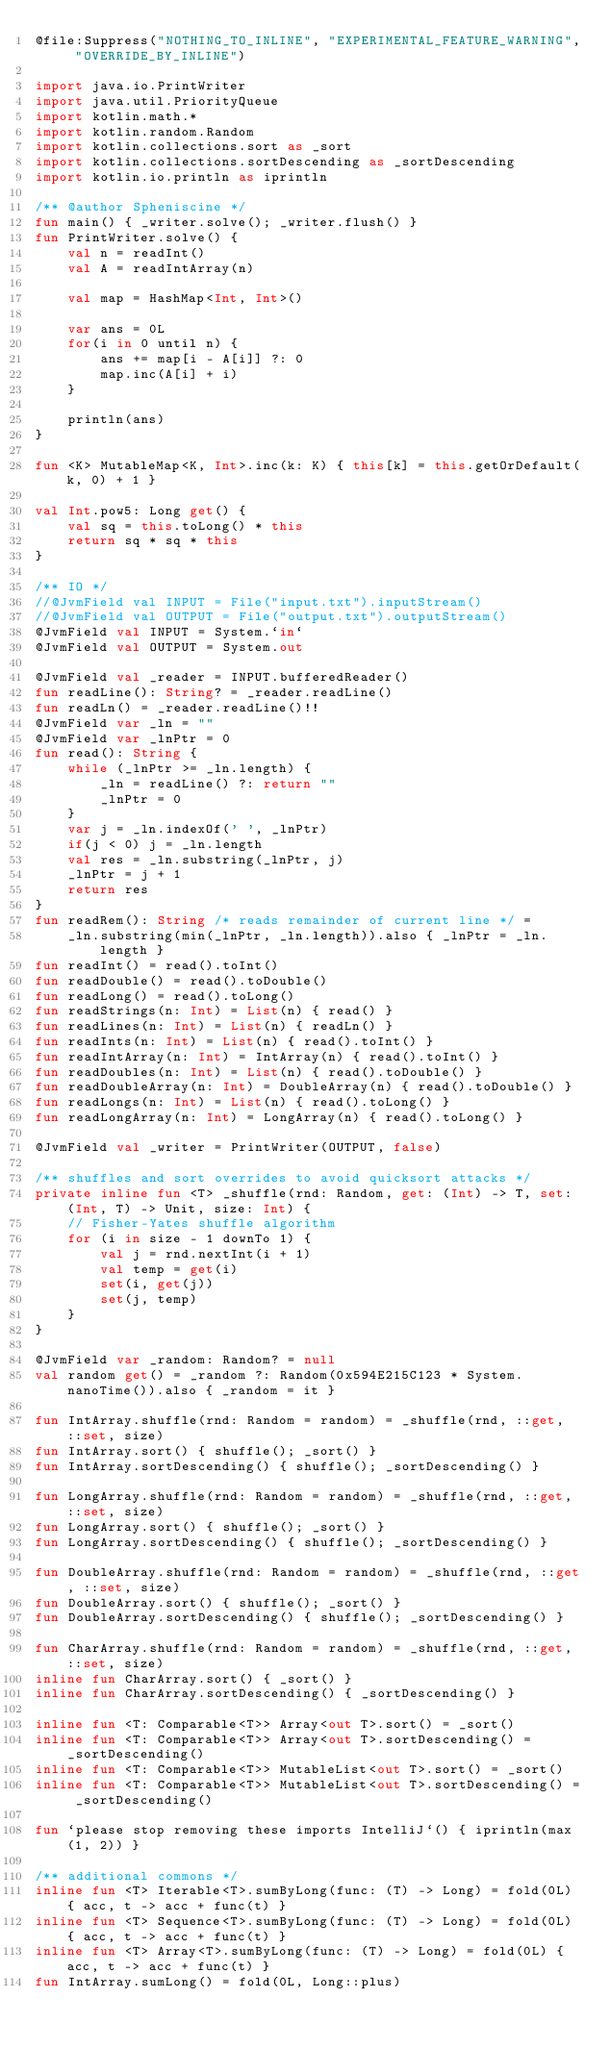Convert code to text. <code><loc_0><loc_0><loc_500><loc_500><_Kotlin_>@file:Suppress("NOTHING_TO_INLINE", "EXPERIMENTAL_FEATURE_WARNING", "OVERRIDE_BY_INLINE")

import java.io.PrintWriter
import java.util.PriorityQueue
import kotlin.math.*
import kotlin.random.Random
import kotlin.collections.sort as _sort
import kotlin.collections.sortDescending as _sortDescending
import kotlin.io.println as iprintln

/** @author Spheniscine */
fun main() { _writer.solve(); _writer.flush() }
fun PrintWriter.solve() {
    val n = readInt()
    val A = readIntArray(n)

    val map = HashMap<Int, Int>()

    var ans = 0L
    for(i in 0 until n) {
        ans += map[i - A[i]] ?: 0
        map.inc(A[i] + i)
    }

    println(ans)
}

fun <K> MutableMap<K, Int>.inc(k: K) { this[k] = this.getOrDefault(k, 0) + 1 }

val Int.pow5: Long get() {
    val sq = this.toLong() * this
    return sq * sq * this
}

/** IO */
//@JvmField val INPUT = File("input.txt").inputStream()
//@JvmField val OUTPUT = File("output.txt").outputStream()
@JvmField val INPUT = System.`in`
@JvmField val OUTPUT = System.out

@JvmField val _reader = INPUT.bufferedReader()
fun readLine(): String? = _reader.readLine()
fun readLn() = _reader.readLine()!!
@JvmField var _ln = ""
@JvmField var _lnPtr = 0
fun read(): String {
    while (_lnPtr >= _ln.length) {
        _ln = readLine() ?: return ""
        _lnPtr = 0
    }
    var j = _ln.indexOf(' ', _lnPtr)
    if(j < 0) j = _ln.length
    val res = _ln.substring(_lnPtr, j)
    _lnPtr = j + 1
    return res
}
fun readRem(): String /* reads remainder of current line */ =
    _ln.substring(min(_lnPtr, _ln.length)).also { _lnPtr = _ln.length }
fun readInt() = read().toInt()
fun readDouble() = read().toDouble()
fun readLong() = read().toLong()
fun readStrings(n: Int) = List(n) { read() }
fun readLines(n: Int) = List(n) { readLn() }
fun readInts(n: Int) = List(n) { read().toInt() }
fun readIntArray(n: Int) = IntArray(n) { read().toInt() }
fun readDoubles(n: Int) = List(n) { read().toDouble() }
fun readDoubleArray(n: Int) = DoubleArray(n) { read().toDouble() }
fun readLongs(n: Int) = List(n) { read().toLong() }
fun readLongArray(n: Int) = LongArray(n) { read().toLong() }

@JvmField val _writer = PrintWriter(OUTPUT, false)

/** shuffles and sort overrides to avoid quicksort attacks */
private inline fun <T> _shuffle(rnd: Random, get: (Int) -> T, set: (Int, T) -> Unit, size: Int) {
    // Fisher-Yates shuffle algorithm
    for (i in size - 1 downTo 1) {
        val j = rnd.nextInt(i + 1)
        val temp = get(i)
        set(i, get(j))
        set(j, temp)
    }
}

@JvmField var _random: Random? = null
val random get() = _random ?: Random(0x594E215C123 * System.nanoTime()).also { _random = it }

fun IntArray.shuffle(rnd: Random = random) = _shuffle(rnd, ::get, ::set, size)
fun IntArray.sort() { shuffle(); _sort() }
fun IntArray.sortDescending() { shuffle(); _sortDescending() }

fun LongArray.shuffle(rnd: Random = random) = _shuffle(rnd, ::get, ::set, size)
fun LongArray.sort() { shuffle(); _sort() }
fun LongArray.sortDescending() { shuffle(); _sortDescending() }

fun DoubleArray.shuffle(rnd: Random = random) = _shuffle(rnd, ::get, ::set, size)
fun DoubleArray.sort() { shuffle(); _sort() }
fun DoubleArray.sortDescending() { shuffle(); _sortDescending() }

fun CharArray.shuffle(rnd: Random = random) = _shuffle(rnd, ::get, ::set, size)
inline fun CharArray.sort() { _sort() }
inline fun CharArray.sortDescending() { _sortDescending() }

inline fun <T: Comparable<T>> Array<out T>.sort() = _sort()
inline fun <T: Comparable<T>> Array<out T>.sortDescending() = _sortDescending()
inline fun <T: Comparable<T>> MutableList<out T>.sort() = _sort()
inline fun <T: Comparable<T>> MutableList<out T>.sortDescending() = _sortDescending()

fun `please stop removing these imports IntelliJ`() { iprintln(max(1, 2)) }

/** additional commons */
inline fun <T> Iterable<T>.sumByLong(func: (T) -> Long) = fold(0L) { acc, t -> acc + func(t) }
inline fun <T> Sequence<T>.sumByLong(func: (T) -> Long) = fold(0L) { acc, t -> acc + func(t) }
inline fun <T> Array<T>.sumByLong(func: (T) -> Long) = fold(0L) { acc, t -> acc + func(t) }
fun IntArray.sumLong() = fold(0L, Long::plus)
</code> 